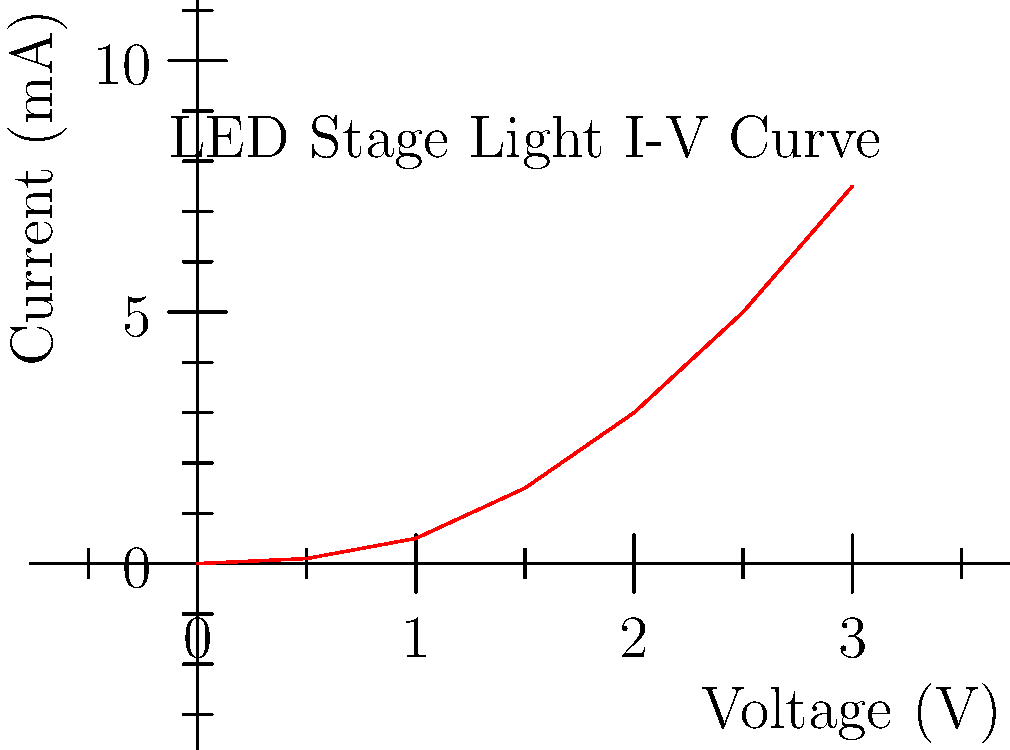During a reunion performance, your ballet group is using LED stage lights. You're asked to analyze the current-voltage characteristic curve of these lights. Given the I-V curve above, at what voltage does the LED start to conduct significant current (often called the "knee" voltage)? To determine the "knee" voltage of the LED stage light, we need to analyze the current-voltage (I-V) characteristic curve:

1. The I-V curve shows the relationship between voltage applied to the LED and the current flowing through it.
2. At low voltages, very little current flows through the LED. This is the "off" state.
3. As voltage increases, there's a point where current starts to increase rapidly. This point is called the "knee" voltage.
4. To find the knee voltage:
   a. Look for a sudden increase in the slope of the curve.
   b. This occurs around the point where the curve starts to bend upward sharply.
5. In this graph, we can see that the curve remains relatively flat until about 1.5V.
6. After 1.5V, the current starts to increase more rapidly.
7. Therefore, the knee voltage for this LED stage light is approximately 1.5V.

This knee voltage is crucial for lighting designers, as it represents the minimum voltage required to produce visible light output from the LED.
Answer: 1.5V 